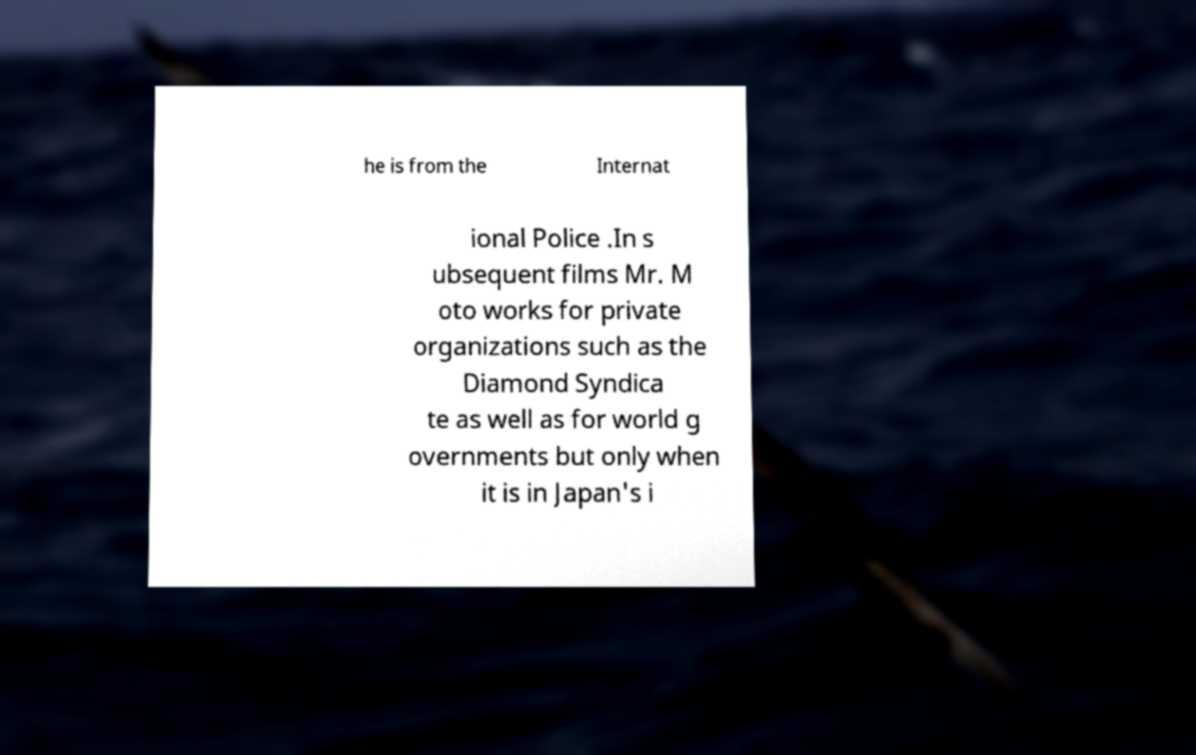For documentation purposes, I need the text within this image transcribed. Could you provide that? he is from the Internat ional Police .In s ubsequent films Mr. M oto works for private organizations such as the Diamond Syndica te as well as for world g overnments but only when it is in Japan's i 